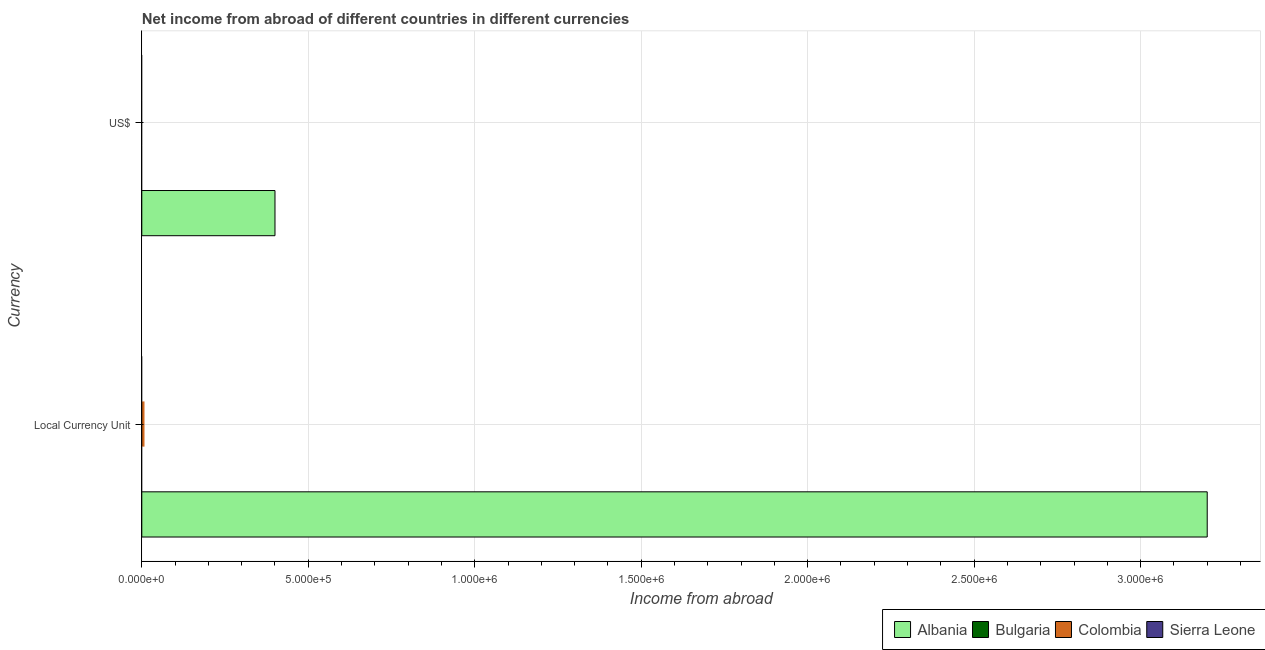Are the number of bars on each tick of the Y-axis equal?
Offer a very short reply. Yes. How many bars are there on the 1st tick from the top?
Your answer should be very brief. 1. What is the label of the 1st group of bars from the top?
Your response must be concise. US$. Across all countries, what is the maximum income from abroad in constant 2005 us$?
Offer a very short reply. 3.20e+06. In which country was the income from abroad in constant 2005 us$ maximum?
Offer a terse response. Albania. What is the total income from abroad in us$ in the graph?
Ensure brevity in your answer.  4.00e+05. What is the difference between the income from abroad in constant 2005 us$ in Bulgaria and the income from abroad in us$ in Sierra Leone?
Your answer should be very brief. 0. In how many countries, is the income from abroad in us$ greater than the average income from abroad in us$ taken over all countries?
Ensure brevity in your answer.  1. Are all the bars in the graph horizontal?
Your response must be concise. Yes. How many countries are there in the graph?
Offer a terse response. 4. What is the difference between two consecutive major ticks on the X-axis?
Your answer should be very brief. 5.00e+05. Does the graph contain any zero values?
Keep it short and to the point. Yes. Where does the legend appear in the graph?
Ensure brevity in your answer.  Bottom right. What is the title of the graph?
Keep it short and to the point. Net income from abroad of different countries in different currencies. What is the label or title of the X-axis?
Keep it short and to the point. Income from abroad. What is the label or title of the Y-axis?
Give a very brief answer. Currency. What is the Income from abroad of Albania in Local Currency Unit?
Your response must be concise. 3.20e+06. What is the Income from abroad of Colombia in Local Currency Unit?
Make the answer very short. 0. What is the Income from abroad in Sierra Leone in Local Currency Unit?
Keep it short and to the point. 0. What is the Income from abroad in Bulgaria in US$?
Your response must be concise. 0. What is the Income from abroad of Colombia in US$?
Keep it short and to the point. 0. Across all Currency, what is the maximum Income from abroad of Albania?
Provide a succinct answer. 3.20e+06. What is the total Income from abroad in Albania in the graph?
Your answer should be very brief. 3.60e+06. What is the total Income from abroad in Bulgaria in the graph?
Offer a terse response. 0. What is the total Income from abroad of Colombia in the graph?
Ensure brevity in your answer.  0. What is the total Income from abroad in Sierra Leone in the graph?
Your answer should be compact. 0. What is the difference between the Income from abroad of Albania in Local Currency Unit and that in US$?
Provide a succinct answer. 2.80e+06. What is the average Income from abroad of Albania per Currency?
Ensure brevity in your answer.  1.80e+06. What is the ratio of the Income from abroad of Albania in Local Currency Unit to that in US$?
Make the answer very short. 8. What is the difference between the highest and the second highest Income from abroad of Albania?
Keep it short and to the point. 2.80e+06. What is the difference between the highest and the lowest Income from abroad of Albania?
Keep it short and to the point. 2.80e+06. 